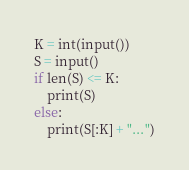Convert code to text. <code><loc_0><loc_0><loc_500><loc_500><_Python_>K = int(input())
S = input()
if len(S) <= K:
    print(S)
else:
    print(S[:K] + "...")</code> 